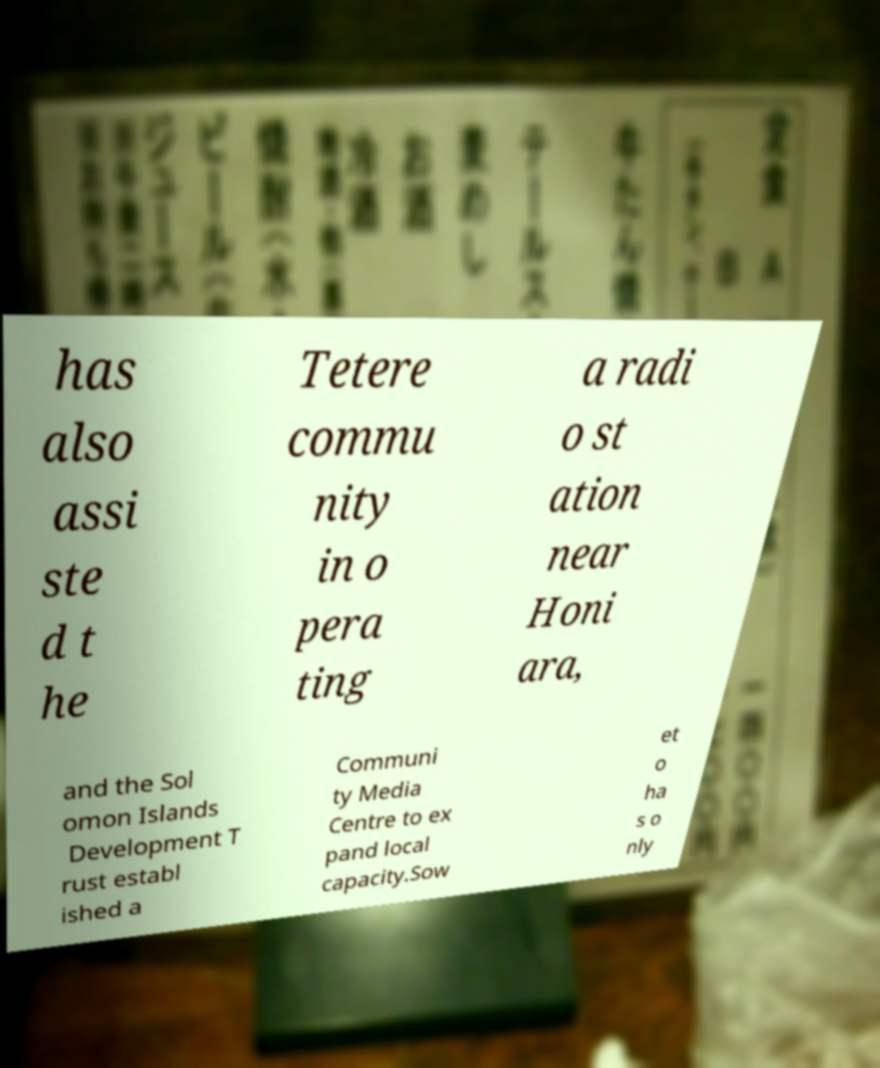Please read and relay the text visible in this image. What does it say? has also assi ste d t he Tetere commu nity in o pera ting a radi o st ation near Honi ara, and the Sol omon Islands Development T rust establ ished a Communi ty Media Centre to ex pand local capacity.Sow et o ha s o nly 